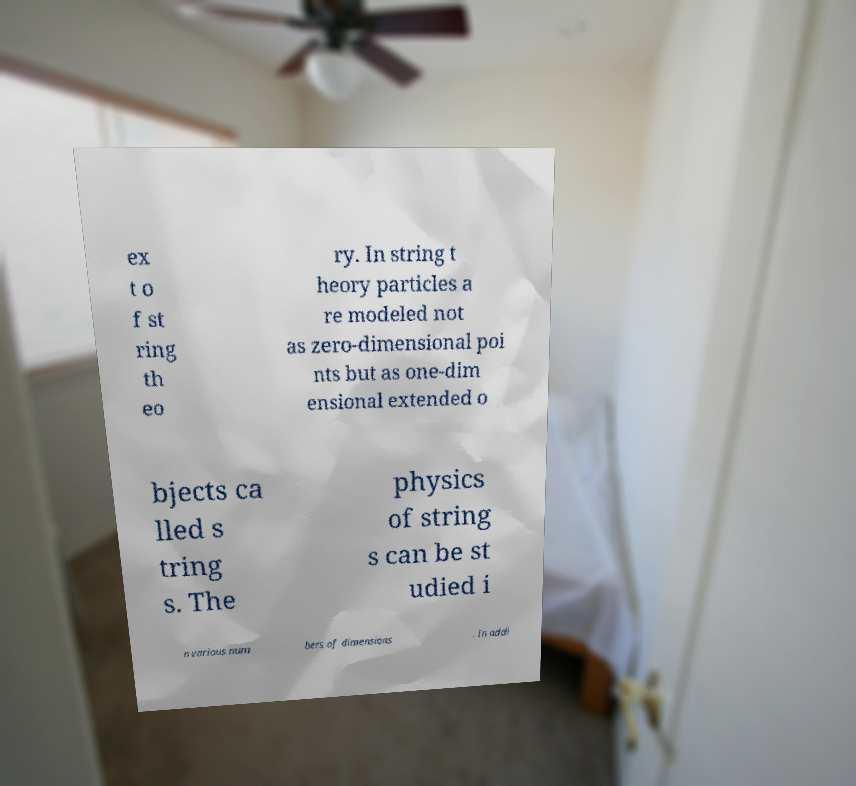Can you accurately transcribe the text from the provided image for me? ex t o f st ring th eo ry. In string t heory particles a re modeled not as zero-dimensional poi nts but as one-dim ensional extended o bjects ca lled s tring s. The physics of string s can be st udied i n various num bers of dimensions . In addi 